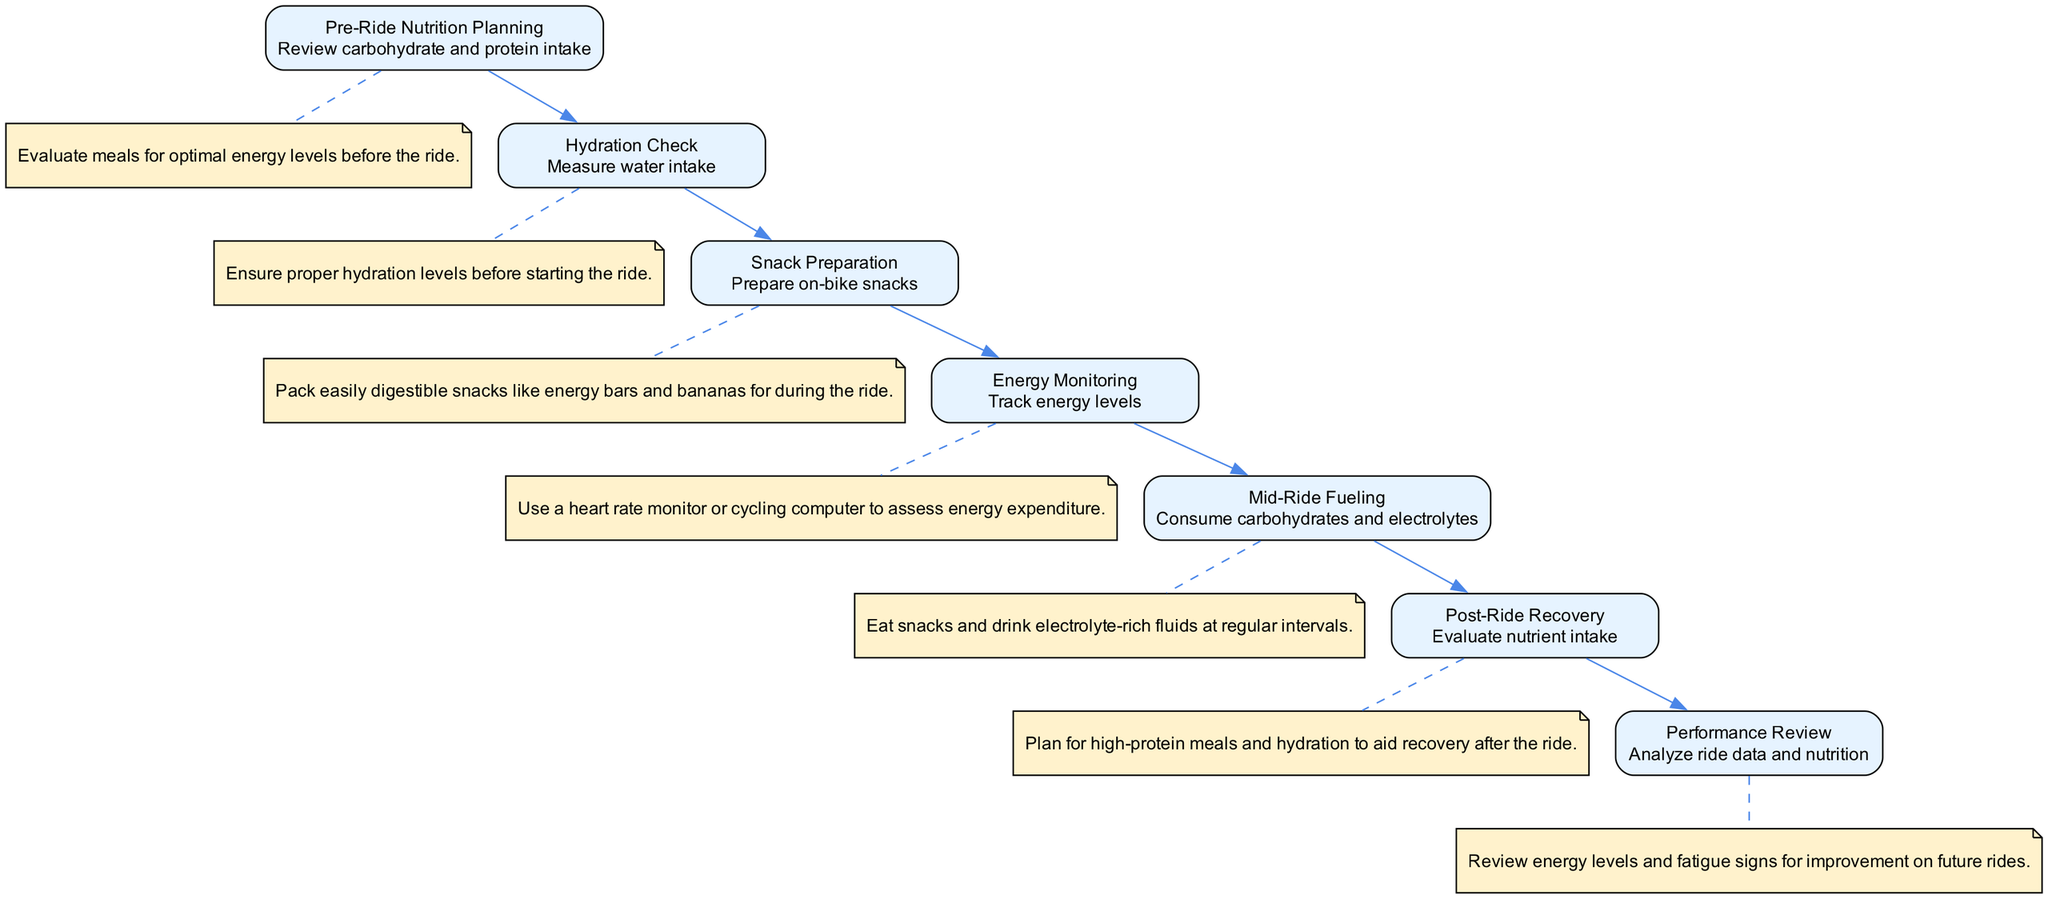What is the first action in the diagram? The first action listed in the sequence diagram is "Review carbohydrate and protein intake," which is part of the "Pre-Ride Nutrition Planning" element.
Answer: Review carbohydrate and protein intake How many elements are included in the diagram? The diagram includes seven elements, each representing a specific aspect of nutritional planning for cycling.
Answer: seven What is the action taken during the Mid-Ride Fueling? During the Mid-Ride Fueling, the action taken is "Consume carbohydrates and electrolytes," which focuses on in-ride nutrition.
Answer: Consume carbohydrates and electrolytes Which element follows the Snack Preparation? The element that follows Snack Preparation is "Energy Monitoring," indicating the sequence of checking energy levels after preparing snacks.
Answer: Energy Monitoring What type of note is connected to the Pre-Ride Nutrition Planning? The note connected to the Pre-Ride Nutrition Planning describes the action as "Evaluate meals for optimal energy levels before the ride."
Answer: Evaluate meals for optimal energy levels before the ride What is the last step in the sequence? The last step in the sequence is "Analyze ride data and nutrition," which aims to review performance and guide future preparation.
Answer: Analyze ride data and nutrition Which action indicates the necessity of hydration before riding? The action "Measure water intake," which is part of the "Hydration Check," underscores the importance of hydration before starting the ride.
Answer: Measure water intake What is the primary focus of the Post-Ride Recovery? The primary focus of the Post-Ride Recovery is to "Evaluate nutrient intake," ensuring proper replenishment after the ride.
Answer: Evaluate nutrient intake 